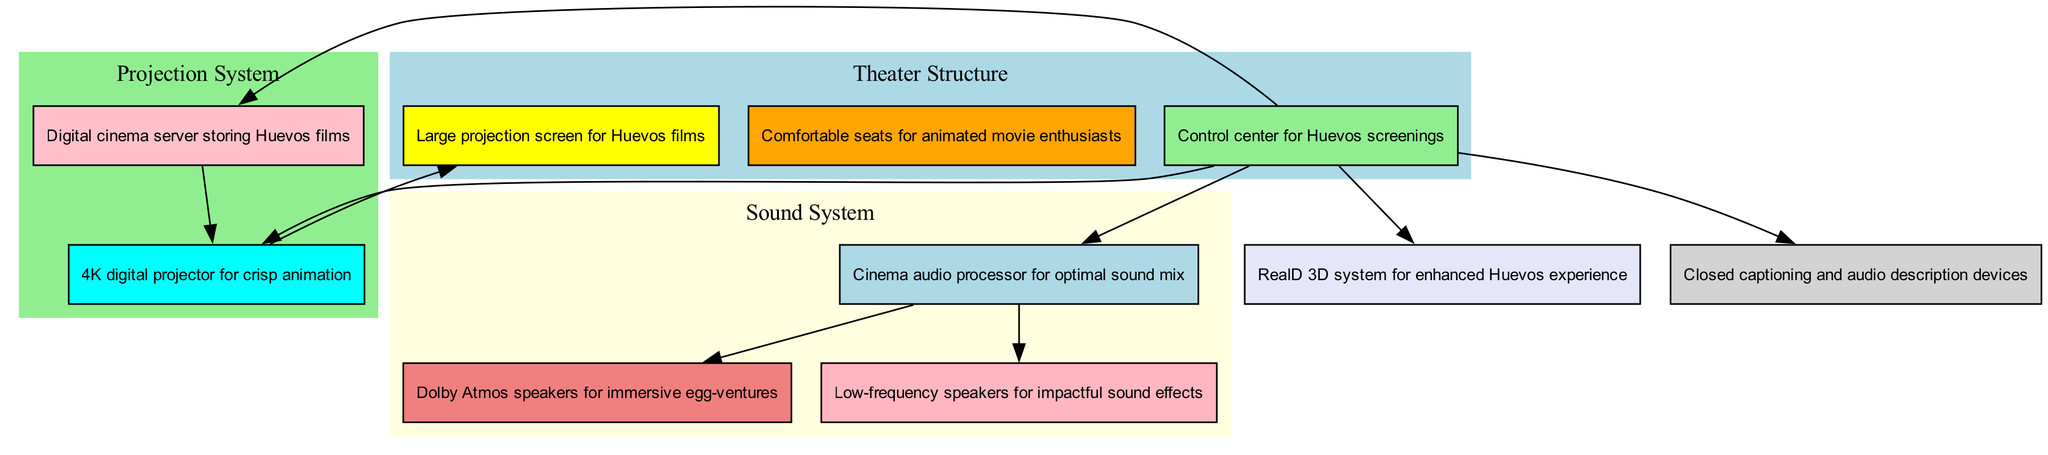What is the primary screen type used for animated films? The diagram specifically mentions a "Large projection screen for Huevos films" located in the theater structure section. This node directly answers the question about the primary screen type used.
Answer: Large projection screen for Huevos films How many main sections are represented in the diagram? The diagram shows four main sections which include Theater Structure, Projection System, Sound System, and Additional Features. By counting each of these clusters, we find that the number is four.
Answer: 4 What kind of audio processing is indicated in the sound system? The sound system section lists "Cinema audio processor for optimal sound mix," which clearly indicates the type of audio processing used in the theater.
Answer: Cinema audio processor for optimal sound mix Which feature is related to enhanced viewing experiences? The Additional Features section includes "RealD 3D system for enhanced Huevos experience," indicating that this feature specifically enhances the viewing experience.
Answer: RealD 3D system for enhanced Huevos experience What types of speakers are included in the sound system configurations? The diagram mentions "Dolby Atmos speakers for immersive egg-ventures" and "Low-frequency speakers for impactful sound effects," indicating various types of speakers. Combining this information gives us a concise answer.
Answer: Dolby Atmos speakers, Low-frequency speakers Which node connects the projection booth to the projection system? The edges from the projection booth connect to both the digital projector and the movie server. Thus, the projection booth connects to the projection system through these nodes. The direct connection can also be seen visually in the diagram.
Answer: projector, server What is the function of the projection booth in the structure? The projection booth is labeled as the "Control center for Huevos screenings," indicating its function within the theater structure. This directly answers the question about its role.
Answer: Control center for Huevos screenings How are the audio components connected in the sound system? The audio processor connects to both the surround speakers and subwoofers, as illustrated by the edges leading from the audio node to these speaker nodes. This illustrates the relationships between these components.
Answer: audio processor connects to speakers and subwoofers What kind of seating is provided in the theater structure? The seating area is described as "Comfortable seats for animated movie enthusiasts," which indicates the type of seating provided.
Answer: Comfortable seats for animated movie enthusiasts 